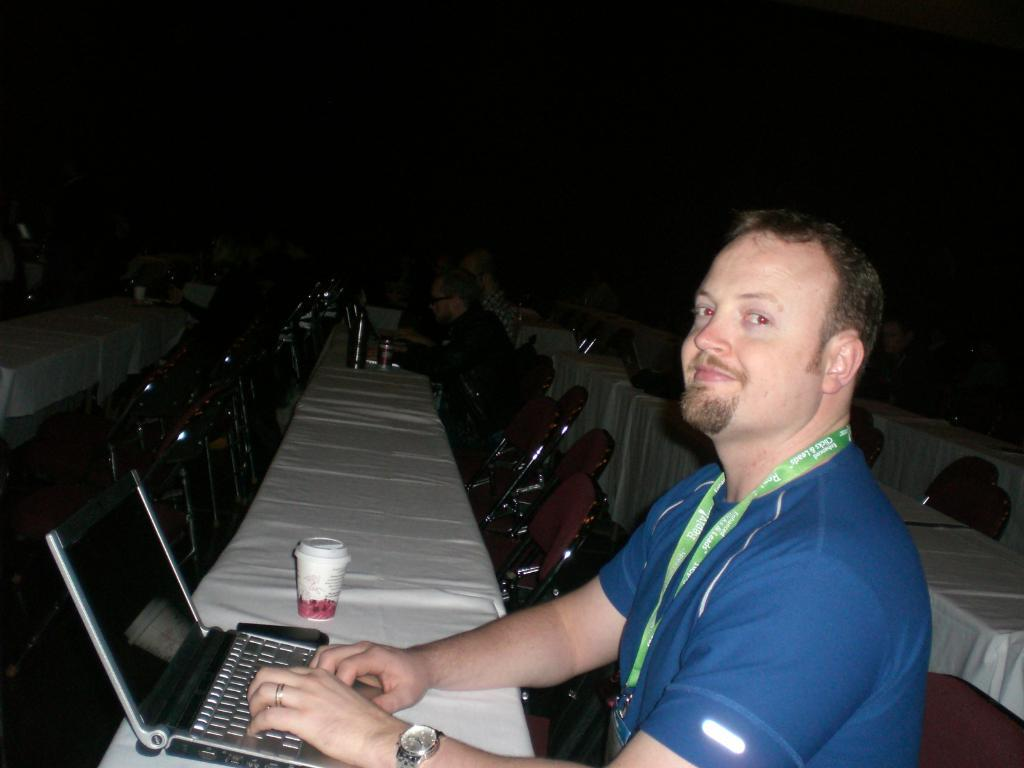What is the person in the image wearing? The person in the image is wearing a blue shirt. What can be seen in the foreground of the image? There is a laptop in the foreground of the image. What is visible in the background of the image? Chairs, people, and tables with objects on them are in the background of the image. What type of mint is being used to play with the balls in the image? There is no mint or balls present in the image. 